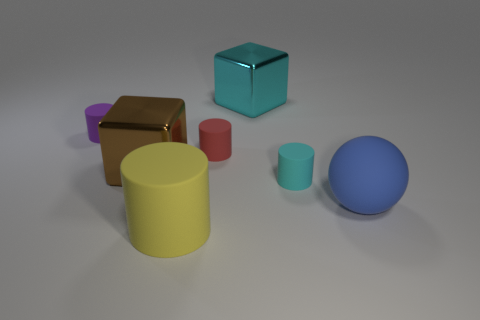Are there any cyan matte objects of the same shape as the big yellow matte thing?
Give a very brief answer. Yes. Do the small red rubber thing and the big thing that is behind the brown block have the same shape?
Give a very brief answer. No. How many cylinders are either small red rubber objects or large metal things?
Give a very brief answer. 1. What shape is the shiny object that is to the right of the brown thing?
Your answer should be compact. Cube. How many other purple things are the same material as the purple object?
Provide a succinct answer. 0. Is the number of cyan cylinders that are in front of the large cyan metal block less than the number of tiny rubber cylinders?
Provide a succinct answer. Yes. There is a rubber cylinder to the left of the large rubber object left of the tiny cyan matte object; how big is it?
Provide a short and direct response. Small. There is a red cylinder that is the same size as the cyan cylinder; what is its material?
Provide a succinct answer. Rubber. Are there fewer big cyan cubes left of the big yellow object than big yellow cylinders left of the small cyan matte thing?
Your answer should be very brief. Yes. There is a small thing that is in front of the big block that is to the left of the cyan cube; what is its shape?
Keep it short and to the point. Cylinder. 